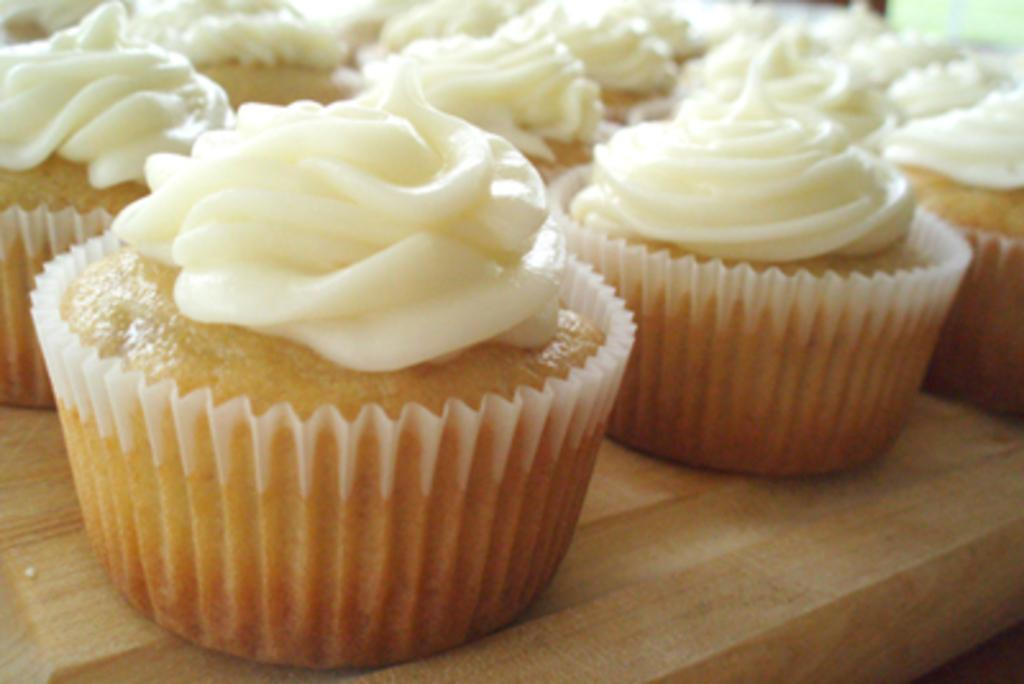What is the focus of the image? The image is zoomed in, focusing on many cupcakes. Where are the cupcakes located in the image? The cupcakes are placed on the top of a table. What invention is being showcased in the image? There is no invention being showcased in the image; it features many cupcakes on a table. What feeling is being expressed by the cupcakes in the image? Cupcakes do not express feelings, as they are inanimate objects. 